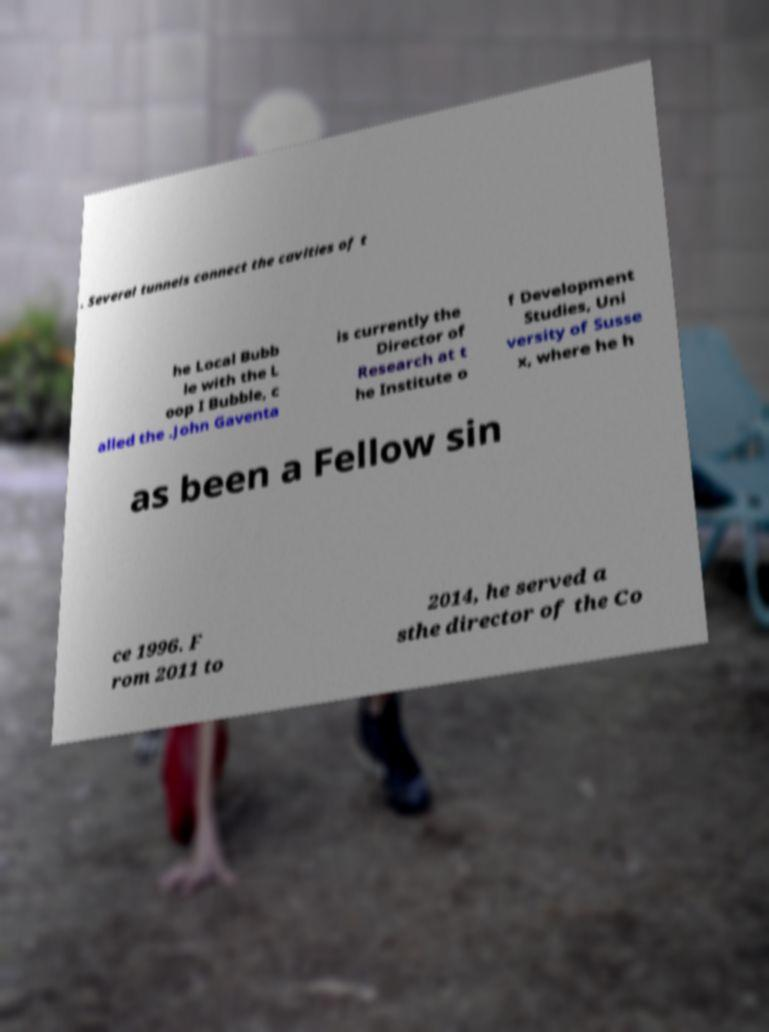For documentation purposes, I need the text within this image transcribed. Could you provide that? . Several tunnels connect the cavities of t he Local Bubb le with the L oop I Bubble, c alled the .John Gaventa is currently the Director of Research at t he Institute o f Development Studies, Uni versity of Susse x, where he h as been a Fellow sin ce 1996. F rom 2011 to 2014, he served a sthe director of the Co 